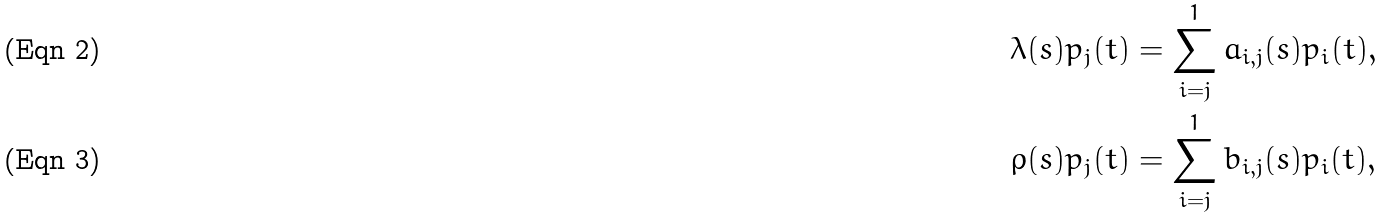Convert formula to latex. <formula><loc_0><loc_0><loc_500><loc_500>\lambda ( s ) p _ { j } ( t ) & = \sum _ { i = j } ^ { 1 } a _ { i , j } ( s ) p _ { i } ( t ) , \\ \rho ( s ) p _ { j } ( t ) & = \sum _ { i = j } ^ { 1 } b _ { i , j } ( s ) p _ { i } ( t ) ,</formula> 